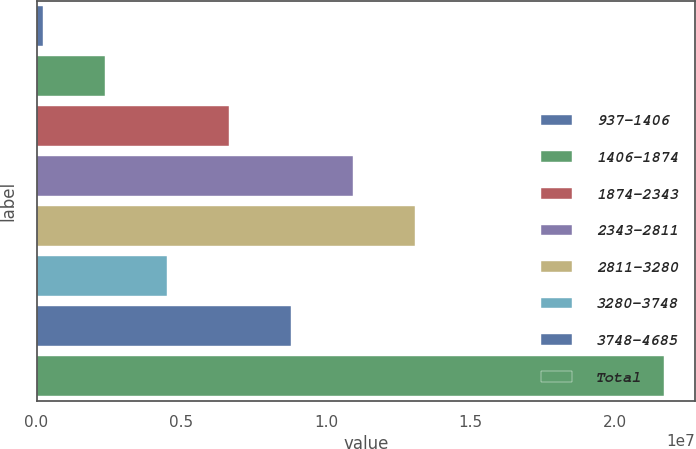Convert chart. <chart><loc_0><loc_0><loc_500><loc_500><bar_chart><fcel>937-1406<fcel>1406-1874<fcel>1874-2343<fcel>2343-2811<fcel>2811-3280<fcel>3280-3748<fcel>3748-4685<fcel>Total<nl><fcel>225747<fcel>2.3706e+06<fcel>6.6603e+06<fcel>1.095e+07<fcel>1.30949e+07<fcel>4.51545e+06<fcel>8.80516e+06<fcel>2.16743e+07<nl></chart> 